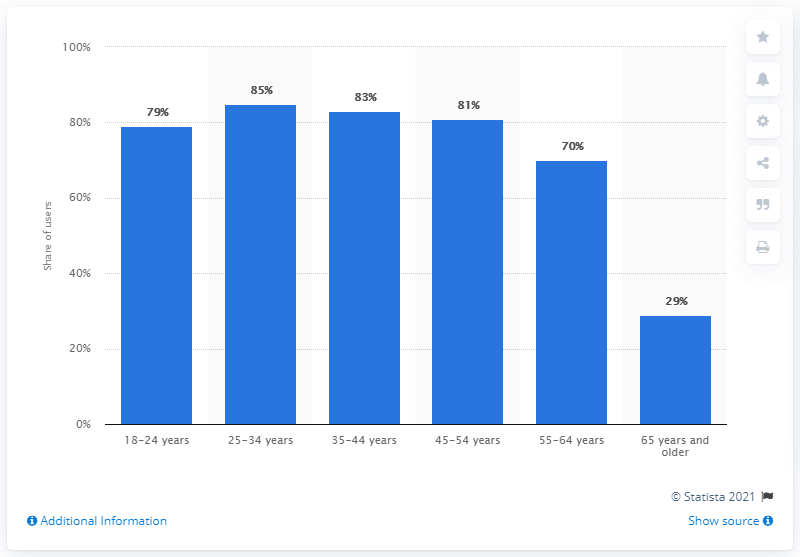List a handful of essential elements in this visual. In November 2019, 29% of users in Italy were aged 65 and older. 